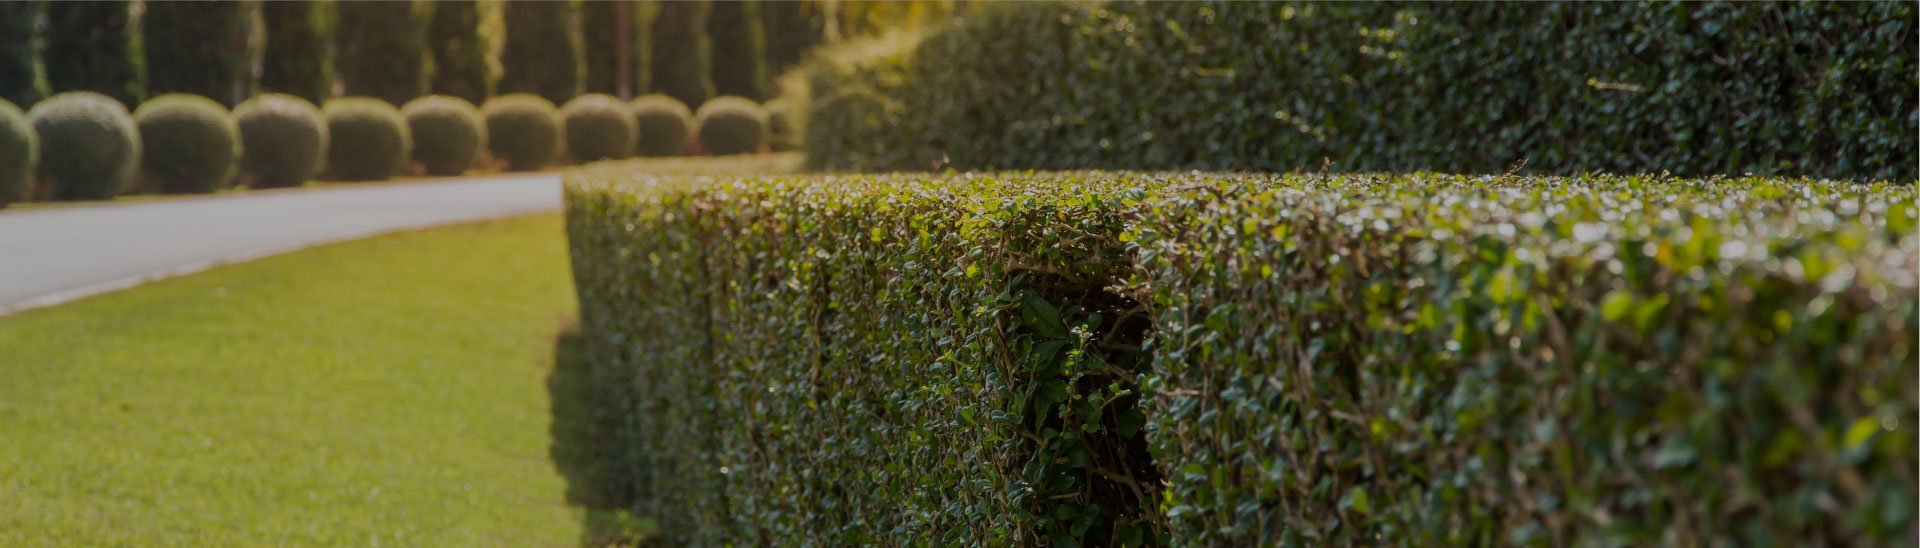Could the design of these hedges and topiaries suggest anything about the cultural or historical influences in garden design? The structured design of these hedges and the spherical topiaries are reminiscent of formal European garden styles, particularly from French and British influences. These styles emphasize symmetry, order, and control of the natural environment, reflecting historical values of beauty and power. The garden’s design could suggest a reverence for these traditional aesthetic principles or might have been inspired by the historical estates of Europe. 